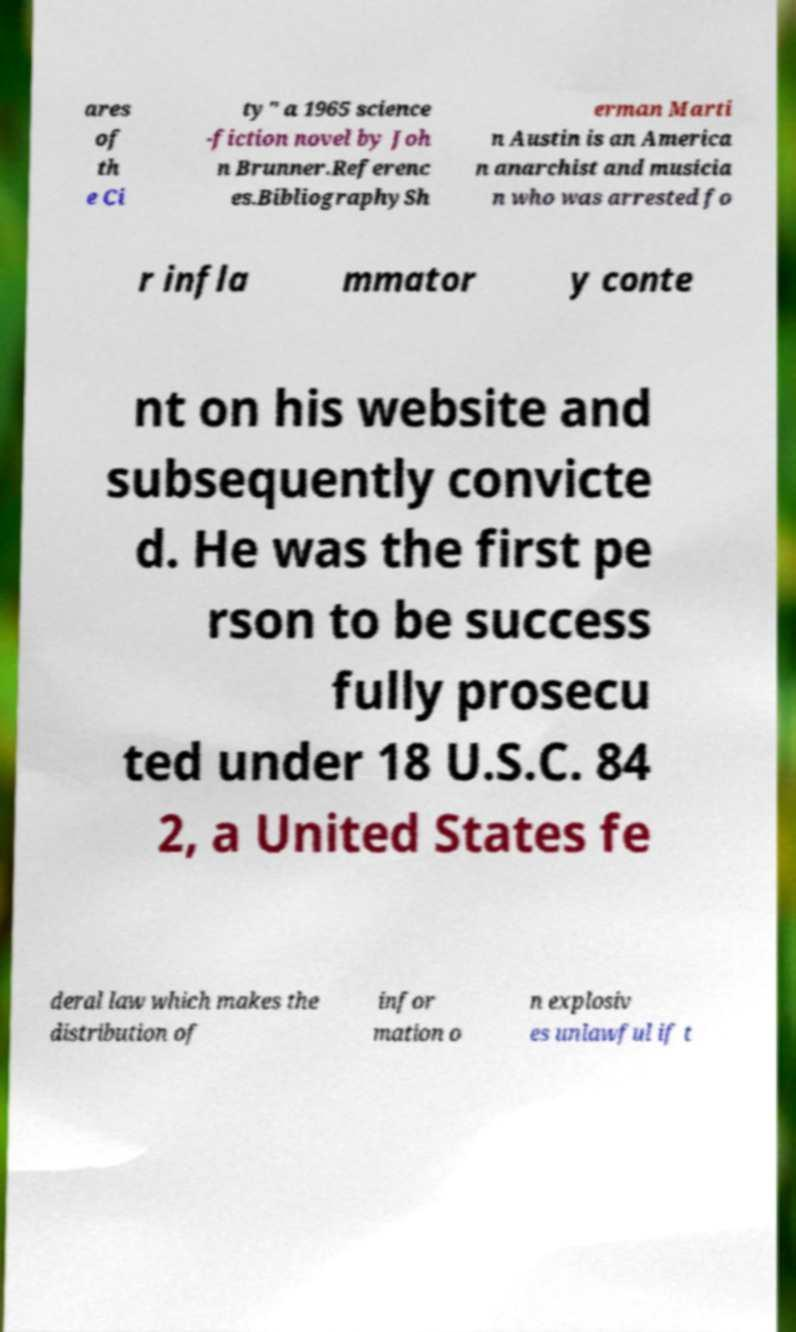I need the written content from this picture converted into text. Can you do that? ares of th e Ci ty" a 1965 science -fiction novel by Joh n Brunner.Referenc es.BibliographySh erman Marti n Austin is an America n anarchist and musicia n who was arrested fo r infla mmator y conte nt on his website and subsequently convicte d. He was the first pe rson to be success fully prosecu ted under 18 U.S.C. 84 2, a United States fe deral law which makes the distribution of infor mation o n explosiv es unlawful if t 